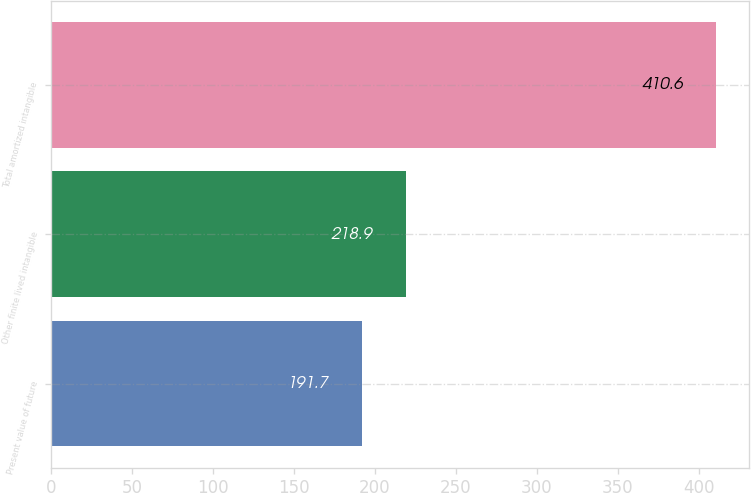Convert chart to OTSL. <chart><loc_0><loc_0><loc_500><loc_500><bar_chart><fcel>Present value of future<fcel>Other finite lived intangible<fcel>Total amortized intangible<nl><fcel>191.7<fcel>218.9<fcel>410.6<nl></chart> 